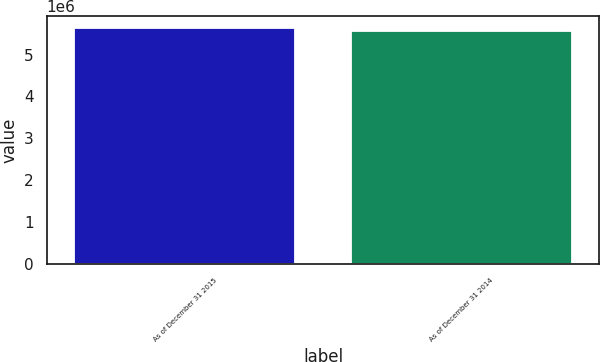<chart> <loc_0><loc_0><loc_500><loc_500><bar_chart><fcel>As of December 31 2015<fcel>As of December 31 2014<nl><fcel>5.6395e+06<fcel>5.55475e+06<nl></chart> 